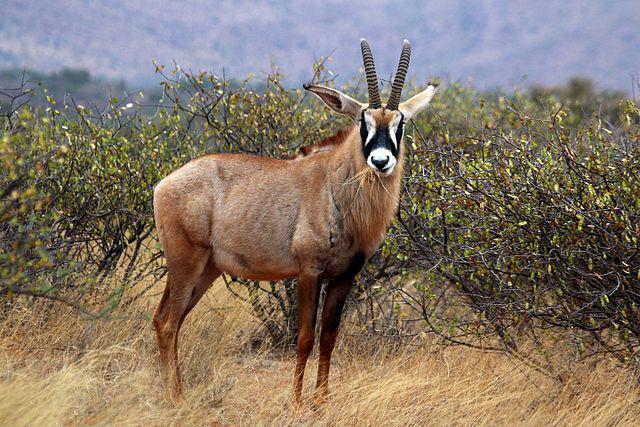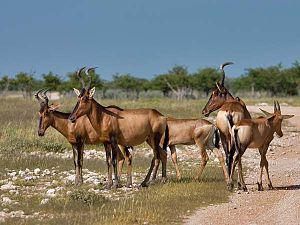The first image is the image on the left, the second image is the image on the right. Evaluate the accuracy of this statement regarding the images: "An image shows exactly five hooved animals with horns.". Is it true? Answer yes or no. Yes. The first image is the image on the left, the second image is the image on the right. For the images displayed, is the sentence "there is exactly one animal in the image on the left" factually correct? Answer yes or no. Yes. 